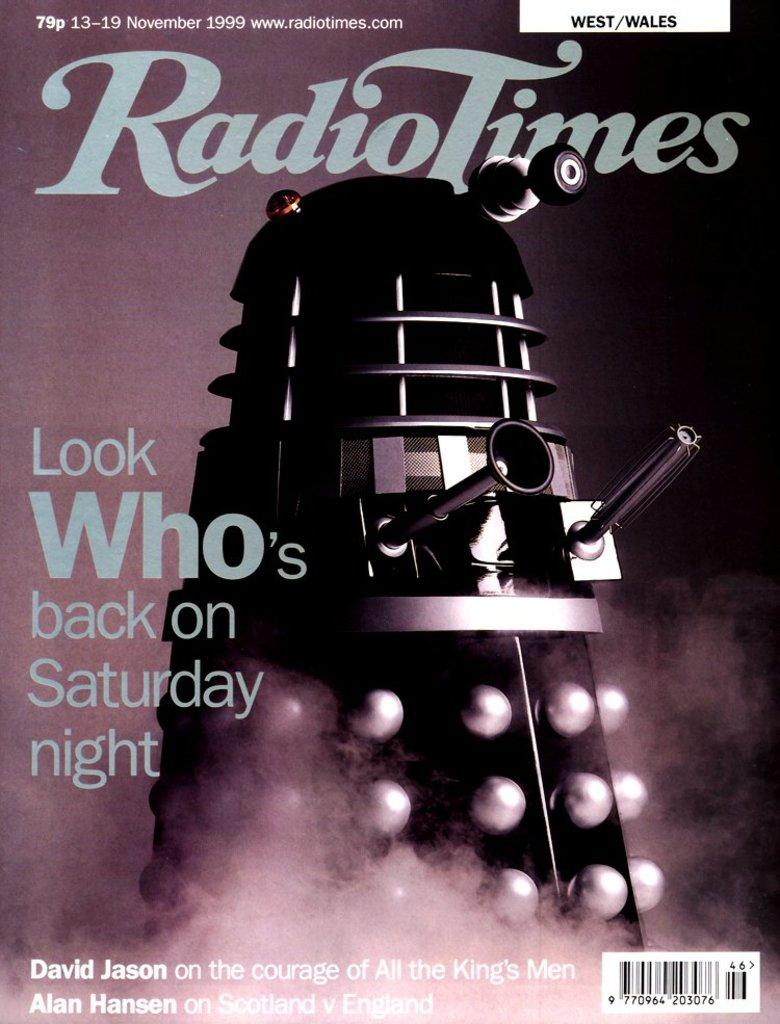<image>
Offer a succinct explanation of the picture presented. The picture shows a copy of the Radio Times from November 1999. 